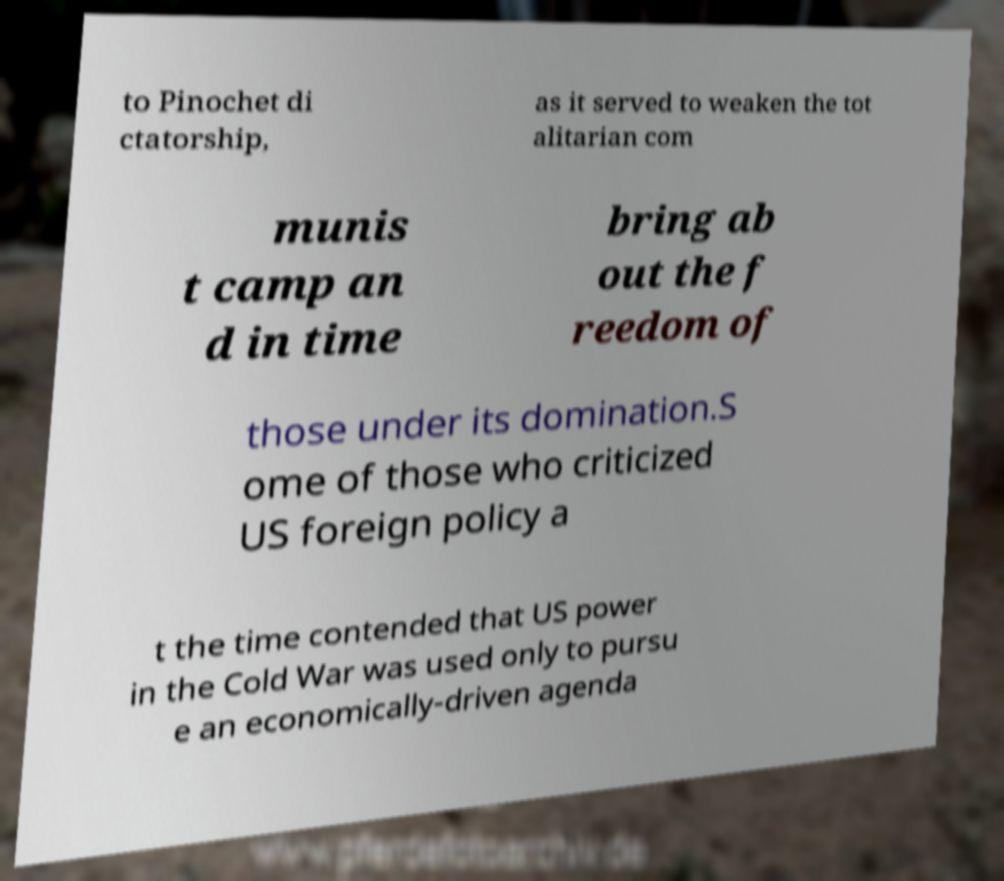Please identify and transcribe the text found in this image. to Pinochet di ctatorship, as it served to weaken the tot alitarian com munis t camp an d in time bring ab out the f reedom of those under its domination.S ome of those who criticized US foreign policy a t the time contended that US power in the Cold War was used only to pursu e an economically-driven agenda 